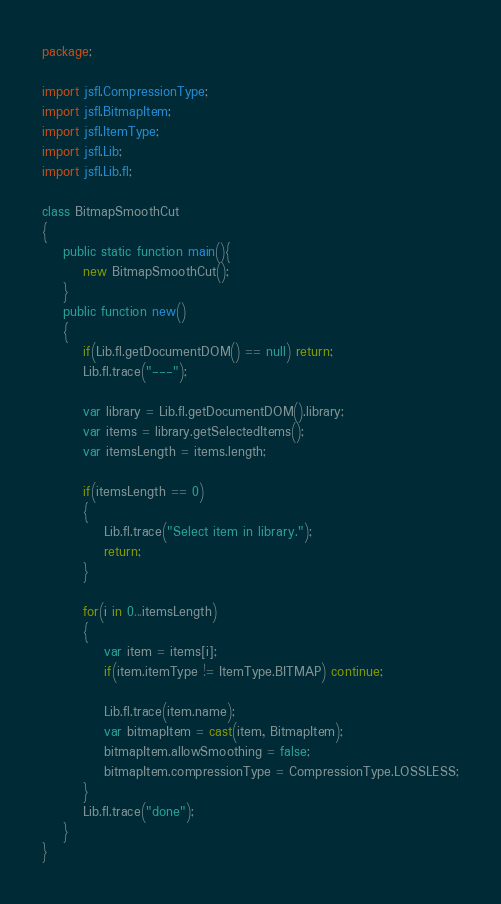Convert code to text. <code><loc_0><loc_0><loc_500><loc_500><_Haxe_>package;

import jsfl.CompressionType;
import jsfl.BitmapItem;
import jsfl.ItemType;
import jsfl.Lib;
import jsfl.Lib.fl;

class BitmapSmoothCut
{
	public static function main(){
		new BitmapSmoothCut();
	}
	public function new()
	{
		if(Lib.fl.getDocumentDOM() == null) return;
		Lib.fl.trace("---");

		var library = Lib.fl.getDocumentDOM().library;
		var items = library.getSelectedItems();
		var itemsLength = items.length;

		if(itemsLength == 0)
		{
			Lib.fl.trace("Select item in library.");
			return;
		}

		for(i in 0...itemsLength)
		{
			var item = items[i];
			if(item.itemType != ItemType.BITMAP) continue;

			Lib.fl.trace(item.name);
			var bitmapItem = cast(item, BitmapItem);
			bitmapItem.allowSmoothing = false;
			bitmapItem.compressionType = CompressionType.LOSSLESS;
		}
		Lib.fl.trace("done");
	}
}
</code> 